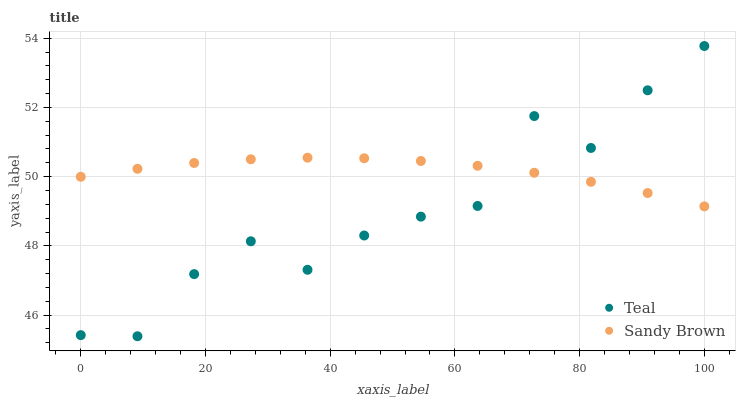Does Teal have the minimum area under the curve?
Answer yes or no. Yes. Does Sandy Brown have the maximum area under the curve?
Answer yes or no. Yes. Does Teal have the maximum area under the curve?
Answer yes or no. No. Is Sandy Brown the smoothest?
Answer yes or no. Yes. Is Teal the roughest?
Answer yes or no. Yes. Is Teal the smoothest?
Answer yes or no. No. Does Teal have the lowest value?
Answer yes or no. Yes. Does Teal have the highest value?
Answer yes or no. Yes. Does Teal intersect Sandy Brown?
Answer yes or no. Yes. Is Teal less than Sandy Brown?
Answer yes or no. No. Is Teal greater than Sandy Brown?
Answer yes or no. No. 